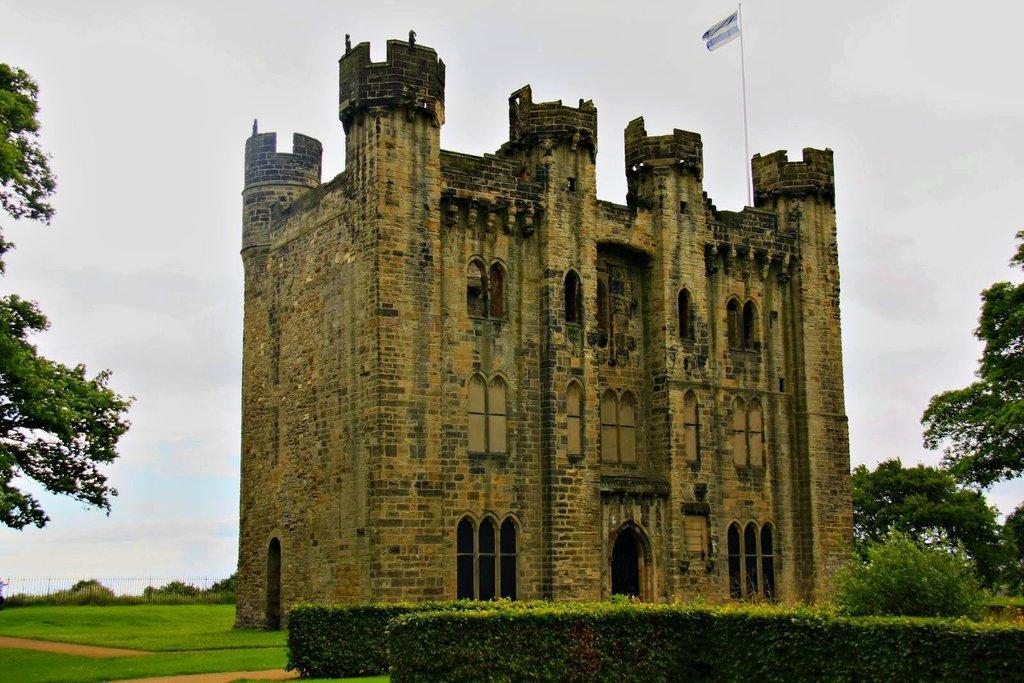Can you describe this image briefly? Here we can see a building, plants, flag, and trees. This is grass and there is a fence. In the background there is sky. 